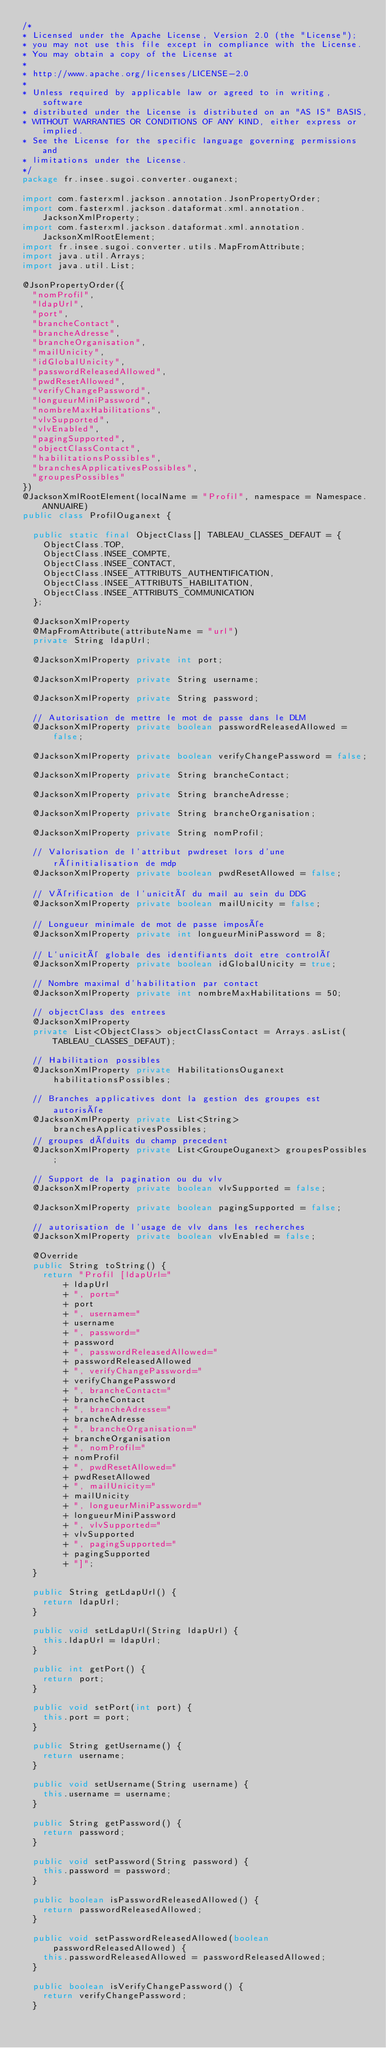Convert code to text. <code><loc_0><loc_0><loc_500><loc_500><_Java_>/*
* Licensed under the Apache License, Version 2.0 (the "License");
* you may not use this file except in compliance with the License.
* You may obtain a copy of the License at
*
* http://www.apache.org/licenses/LICENSE-2.0
*
* Unless required by applicable law or agreed to in writing, software
* distributed under the License is distributed on an "AS IS" BASIS,
* WITHOUT WARRANTIES OR CONDITIONS OF ANY KIND, either express or implied.
* See the License for the specific language governing permissions and
* limitations under the License.
*/
package fr.insee.sugoi.converter.ouganext;

import com.fasterxml.jackson.annotation.JsonPropertyOrder;
import com.fasterxml.jackson.dataformat.xml.annotation.JacksonXmlProperty;
import com.fasterxml.jackson.dataformat.xml.annotation.JacksonXmlRootElement;
import fr.insee.sugoi.converter.utils.MapFromAttribute;
import java.util.Arrays;
import java.util.List;

@JsonPropertyOrder({
  "nomProfil",
  "ldapUrl",
  "port",
  "brancheContact",
  "brancheAdresse",
  "brancheOrganisation",
  "mailUnicity",
  "idGlobalUnicity",
  "passwordReleasedAllowed",
  "pwdResetAllowed",
  "verifyChangePassword",
  "longueurMiniPassword",
  "nombreMaxHabilitations",
  "vlvSupported",
  "vlvEnabled",
  "pagingSupported",
  "objectClassContact",
  "habilitationsPossibles",
  "branchesApplicativesPossibles",
  "groupesPossibles"
})
@JacksonXmlRootElement(localName = "Profil", namespace = Namespace.ANNUAIRE)
public class ProfilOuganext {

  public static final ObjectClass[] TABLEAU_CLASSES_DEFAUT = {
    ObjectClass.TOP,
    ObjectClass.INSEE_COMPTE,
    ObjectClass.INSEE_CONTACT,
    ObjectClass.INSEE_ATTRIBUTS_AUTHENTIFICATION,
    ObjectClass.INSEE_ATTRIBUTS_HABILITATION,
    ObjectClass.INSEE_ATTRIBUTS_COMMUNICATION
  };

  @JacksonXmlProperty
  @MapFromAttribute(attributeName = "url")
  private String ldapUrl;

  @JacksonXmlProperty private int port;

  @JacksonXmlProperty private String username;

  @JacksonXmlProperty private String password;

  // Autorisation de mettre le mot de passe dans le DLM
  @JacksonXmlProperty private boolean passwordReleasedAllowed = false;

  @JacksonXmlProperty private boolean verifyChangePassword = false;

  @JacksonXmlProperty private String brancheContact;

  @JacksonXmlProperty private String brancheAdresse;

  @JacksonXmlProperty private String brancheOrganisation;

  @JacksonXmlProperty private String nomProfil;

  // Valorisation de l'attribut pwdreset lors d'une réinitialisation de mdp
  @JacksonXmlProperty private boolean pwdResetAllowed = false;

  // Vérification de l'unicité du mail au sein du DDG
  @JacksonXmlProperty private boolean mailUnicity = false;

  // Longueur minimale de mot de passe imposée
  @JacksonXmlProperty private int longueurMiniPassword = 8;

  // L'unicité globale des identifiants doit etre controlé
  @JacksonXmlProperty private boolean idGlobalUnicity = true;

  // Nombre maximal d'habilitation par contact
  @JacksonXmlProperty private int nombreMaxHabilitations = 50;

  // objectClass des entrees
  @JacksonXmlProperty
  private List<ObjectClass> objectClassContact = Arrays.asList(TABLEAU_CLASSES_DEFAUT);

  // Habilitation possibles
  @JacksonXmlProperty private HabilitationsOuganext habilitationsPossibles;

  // Branches applicatives dont la gestion des groupes est autorisée
  @JacksonXmlProperty private List<String> branchesApplicativesPossibles;
  // groupes déduits du champ precedent
  @JacksonXmlProperty private List<GroupeOuganext> groupesPossibles;

  // Support de la pagination ou du vlv
  @JacksonXmlProperty private boolean vlvSupported = false;

  @JacksonXmlProperty private boolean pagingSupported = false;

  // autorisation de l'usage de vlv dans les recherches
  @JacksonXmlProperty private boolean vlvEnabled = false;

  @Override
  public String toString() {
    return "Profil [ldapUrl="
        + ldapUrl
        + ", port="
        + port
        + ", username="
        + username
        + ", password="
        + password
        + ", passwordReleasedAllowed="
        + passwordReleasedAllowed
        + ", verifyChangePassword="
        + verifyChangePassword
        + ", brancheContact="
        + brancheContact
        + ", brancheAdresse="
        + brancheAdresse
        + ", brancheOrganisation="
        + brancheOrganisation
        + ", nomProfil="
        + nomProfil
        + ", pwdResetAllowed="
        + pwdResetAllowed
        + ", mailUnicity="
        + mailUnicity
        + ", longueurMiniPassword="
        + longueurMiniPassword
        + ", vlvSupported="
        + vlvSupported
        + ", pagingSupported="
        + pagingSupported
        + "]";
  }

  public String getLdapUrl() {
    return ldapUrl;
  }

  public void setLdapUrl(String ldapUrl) {
    this.ldapUrl = ldapUrl;
  }

  public int getPort() {
    return port;
  }

  public void setPort(int port) {
    this.port = port;
  }

  public String getUsername() {
    return username;
  }

  public void setUsername(String username) {
    this.username = username;
  }

  public String getPassword() {
    return password;
  }

  public void setPassword(String password) {
    this.password = password;
  }

  public boolean isPasswordReleasedAllowed() {
    return passwordReleasedAllowed;
  }

  public void setPasswordReleasedAllowed(boolean passwordReleasedAllowed) {
    this.passwordReleasedAllowed = passwordReleasedAllowed;
  }

  public boolean isVerifyChangePassword() {
    return verifyChangePassword;
  }
</code> 